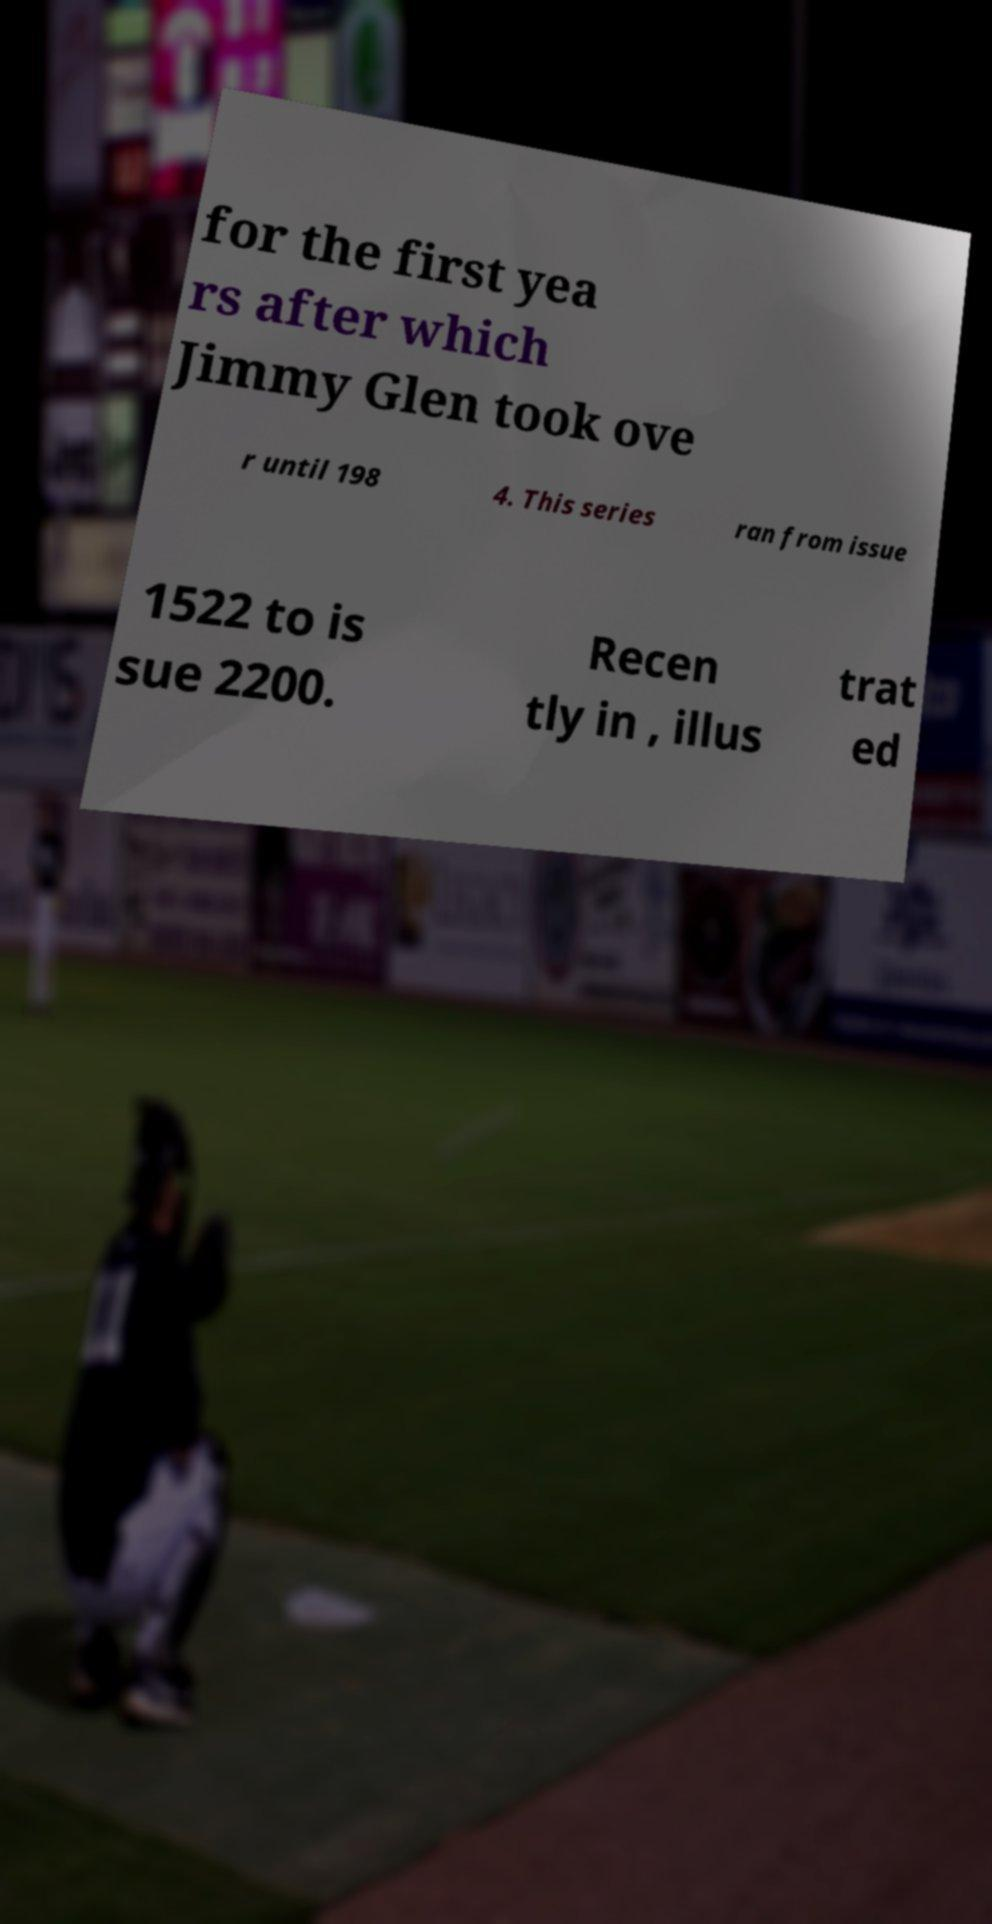Could you assist in decoding the text presented in this image and type it out clearly? for the first yea rs after which Jimmy Glen took ove r until 198 4. This series ran from issue 1522 to is sue 2200. Recen tly in , illus trat ed 